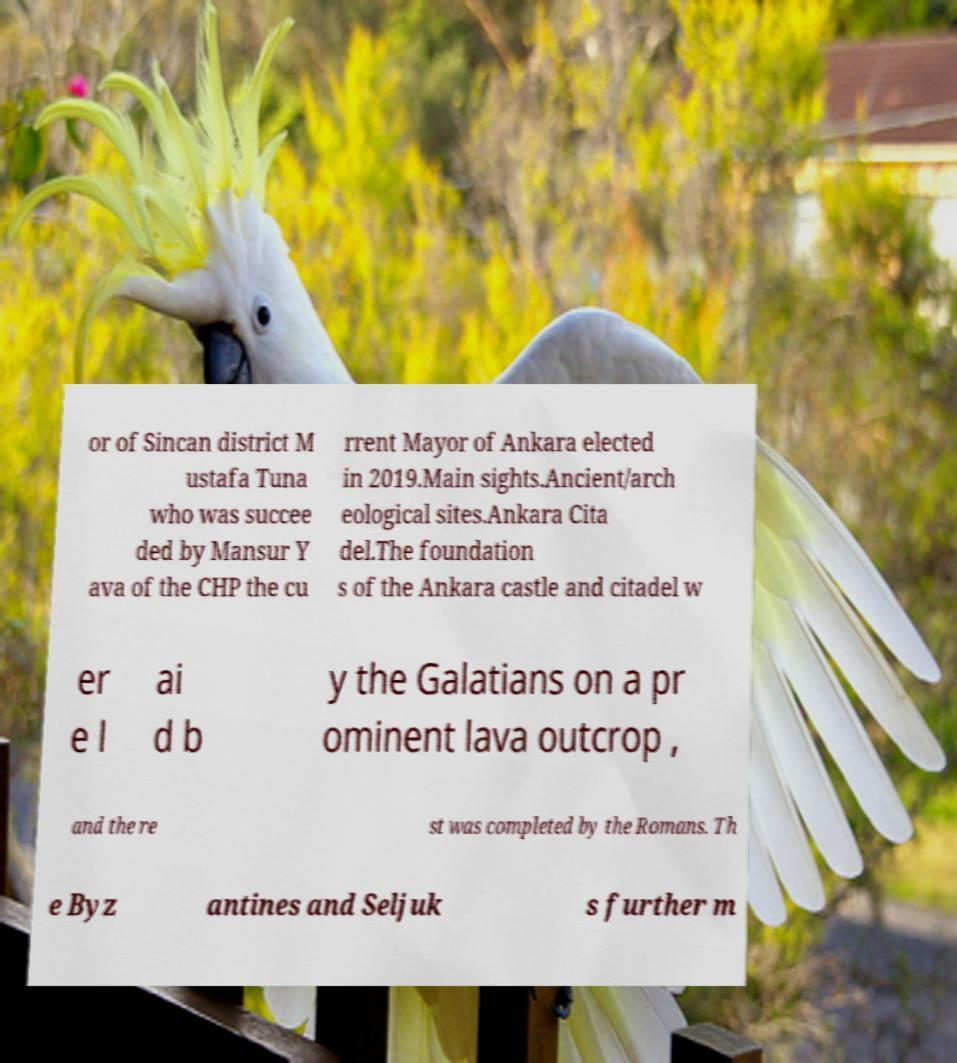What messages or text are displayed in this image? I need them in a readable, typed format. or of Sincan district M ustafa Tuna who was succee ded by Mansur Y ava of the CHP the cu rrent Mayor of Ankara elected in 2019.Main sights.Ancient/arch eological sites.Ankara Cita del.The foundation s of the Ankara castle and citadel w er e l ai d b y the Galatians on a pr ominent lava outcrop , and the re st was completed by the Romans. Th e Byz antines and Seljuk s further m 